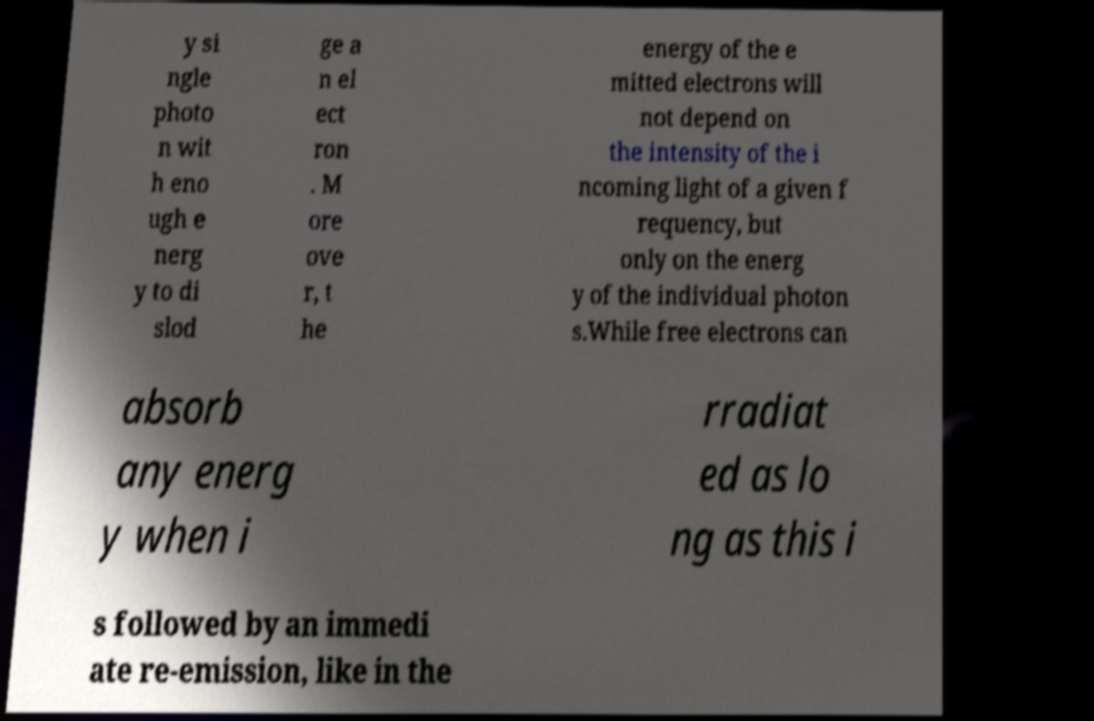What messages or text are displayed in this image? I need them in a readable, typed format. y si ngle photo n wit h eno ugh e nerg y to di slod ge a n el ect ron . M ore ove r, t he energy of the e mitted electrons will not depend on the intensity of the i ncoming light of a given f requency, but only on the energ y of the individual photon s.While free electrons can absorb any energ y when i rradiat ed as lo ng as this i s followed by an immedi ate re-emission, like in the 